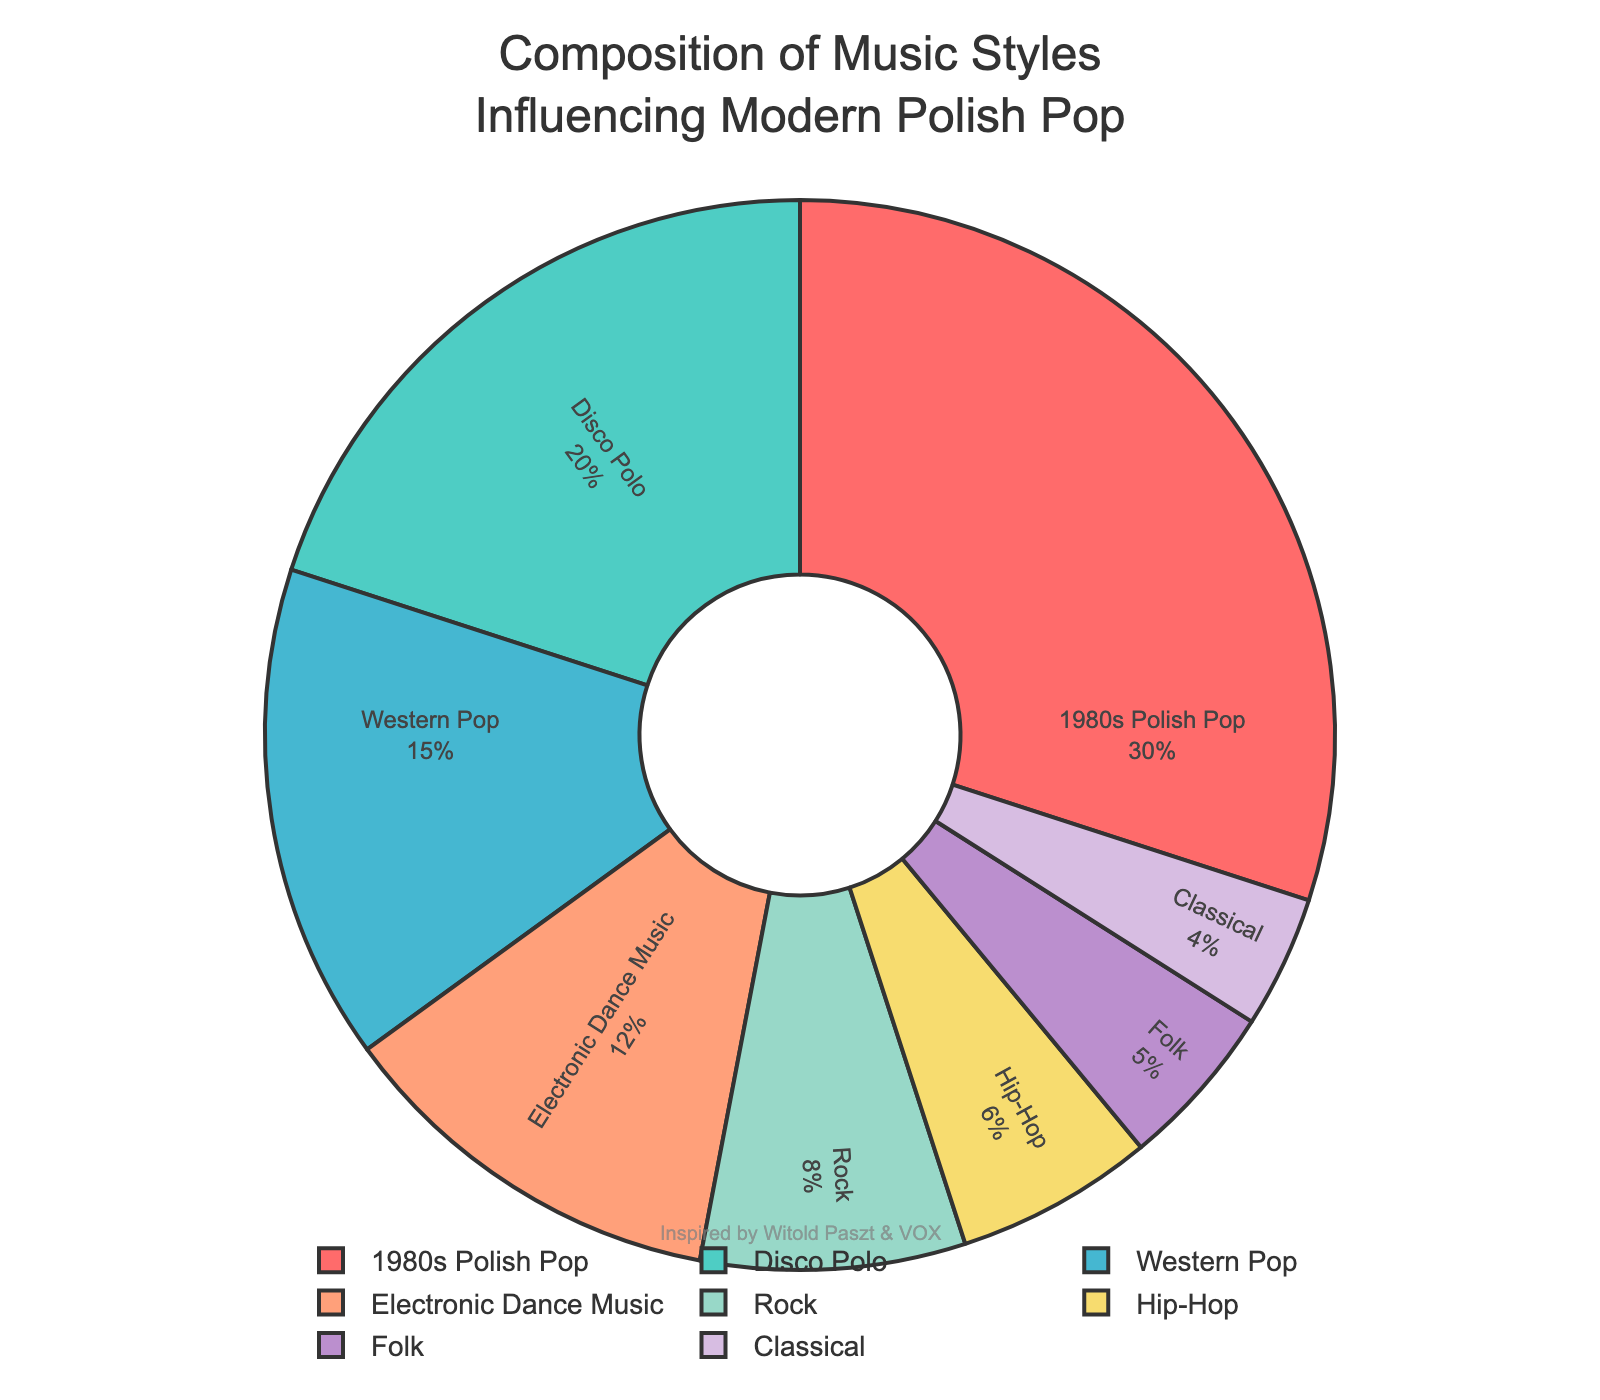Which music style has the highest influence on modern Polish pop music? By looking at the pie chart, the largest segment represents the 1980s Polish Pop which has the highest percentage.
Answer: 1980s Polish Pop How much more influence does 1980s Polish Pop have compared to Hip-Hop? The influence of 1980s Polish Pop is 30% and Hip-Hop is 6%. Subtracting the two gives 30% - 6% = 24%.
Answer: 24% Which two music styles combined have the same influence as Disco Polo? Disco Polo has an influence of 20%. Adding the influence of Folk (5%) and Electronic Dance Music (12%) gives 17%, but adding Rock (8%) and Hip-Hop (6%) gives 8% + 6% = 14%. Since 20% equals Western Pop (15%) and Classical (4%), they sum up to 19%. The final correct one is 1980s Polish Pop (30%) reduces Electronic Dance Music (12%).
Answer: 15% + 5% = 20% What is the color representing Disco Polo segment in the pie chart? By observing the pie chart, find the segment labelled "Disco Polo" and note its color. The color representing Disco Polo is a shade of teal.
Answer: Teal How much influence do Folk and Classical music styles have in total? Summing up the influence percentages of Folk (5%) and Classical (4%) gives 5% + 4% = 9%.
Answer: 9% Which music style has the least influence on modern Polish pop music? Look for the smallest segment in the pie chart, which corresponds to Classical music with 4% influence.
Answer: Classical Is the influence of Rock music greater or less than Hip-Hop? The influence of Rock music is 8%, whereas Hip-Hop is 6%, making Rock greater than Hip-Hop.
Answer: Greater What percentage of the total influence comes from non-Polish music styles? Summing up the Western Pop (15%), Electronic Dance Music (12%), and Hip-Hop (6%) gives 15% + 12% + 6% = 33%.
Answer: 33% If you were to combine the influence of Electronic Dance Music and Hip-Hop, would it exceed the influence of Disco Polo? Electronic Dance Music has 12% and Hip-Hop has 6%. Combined, they make 12% + 6% = 18%, which is less than Disco Polo's 20%.
Answer: No Which has a higher influence: Western Pop or Folk and Classical combined? Western Pop has an influence of 15%. Adding the influence of Folk (5%) and Classical (4%) gives 5% + 4% = 9%. So, Western Pop has higher influence.
Answer: Western Pop 